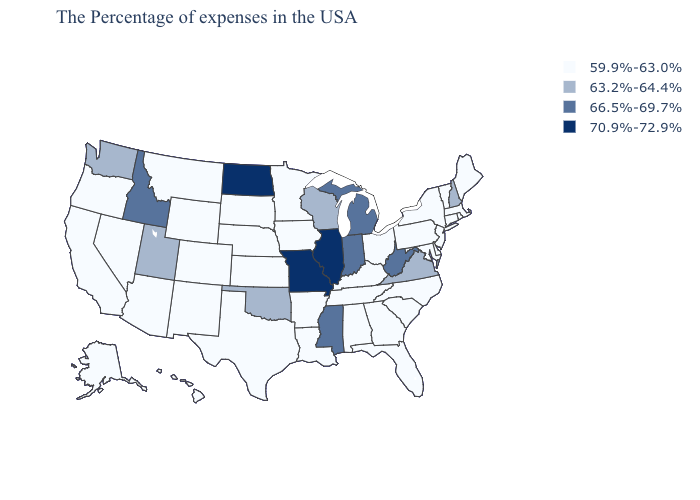What is the value of New York?
Quick response, please. 59.9%-63.0%. Among the states that border Ohio , which have the highest value?
Quick response, please. West Virginia, Michigan, Indiana. What is the value of Maine?
Concise answer only. 59.9%-63.0%. Which states have the lowest value in the USA?
Write a very short answer. Maine, Massachusetts, Rhode Island, Vermont, Connecticut, New York, New Jersey, Delaware, Maryland, Pennsylvania, North Carolina, South Carolina, Ohio, Florida, Georgia, Kentucky, Alabama, Tennessee, Louisiana, Arkansas, Minnesota, Iowa, Kansas, Nebraska, Texas, South Dakota, Wyoming, Colorado, New Mexico, Montana, Arizona, Nevada, California, Oregon, Alaska, Hawaii. Which states hav the highest value in the South?
Short answer required. West Virginia, Mississippi. Does Nevada have the lowest value in the USA?
Short answer required. Yes. Does Missouri have the highest value in the MidWest?
Keep it brief. Yes. Which states have the lowest value in the USA?
Answer briefly. Maine, Massachusetts, Rhode Island, Vermont, Connecticut, New York, New Jersey, Delaware, Maryland, Pennsylvania, North Carolina, South Carolina, Ohio, Florida, Georgia, Kentucky, Alabama, Tennessee, Louisiana, Arkansas, Minnesota, Iowa, Kansas, Nebraska, Texas, South Dakota, Wyoming, Colorado, New Mexico, Montana, Arizona, Nevada, California, Oregon, Alaska, Hawaii. Name the states that have a value in the range 59.9%-63.0%?
Concise answer only. Maine, Massachusetts, Rhode Island, Vermont, Connecticut, New York, New Jersey, Delaware, Maryland, Pennsylvania, North Carolina, South Carolina, Ohio, Florida, Georgia, Kentucky, Alabama, Tennessee, Louisiana, Arkansas, Minnesota, Iowa, Kansas, Nebraska, Texas, South Dakota, Wyoming, Colorado, New Mexico, Montana, Arizona, Nevada, California, Oregon, Alaska, Hawaii. Name the states that have a value in the range 59.9%-63.0%?
Give a very brief answer. Maine, Massachusetts, Rhode Island, Vermont, Connecticut, New York, New Jersey, Delaware, Maryland, Pennsylvania, North Carolina, South Carolina, Ohio, Florida, Georgia, Kentucky, Alabama, Tennessee, Louisiana, Arkansas, Minnesota, Iowa, Kansas, Nebraska, Texas, South Dakota, Wyoming, Colorado, New Mexico, Montana, Arizona, Nevada, California, Oregon, Alaska, Hawaii. What is the value of Pennsylvania?
Write a very short answer. 59.9%-63.0%. What is the value of Missouri?
Give a very brief answer. 70.9%-72.9%. Name the states that have a value in the range 70.9%-72.9%?
Short answer required. Illinois, Missouri, North Dakota. What is the value of Nevada?
Give a very brief answer. 59.9%-63.0%. 